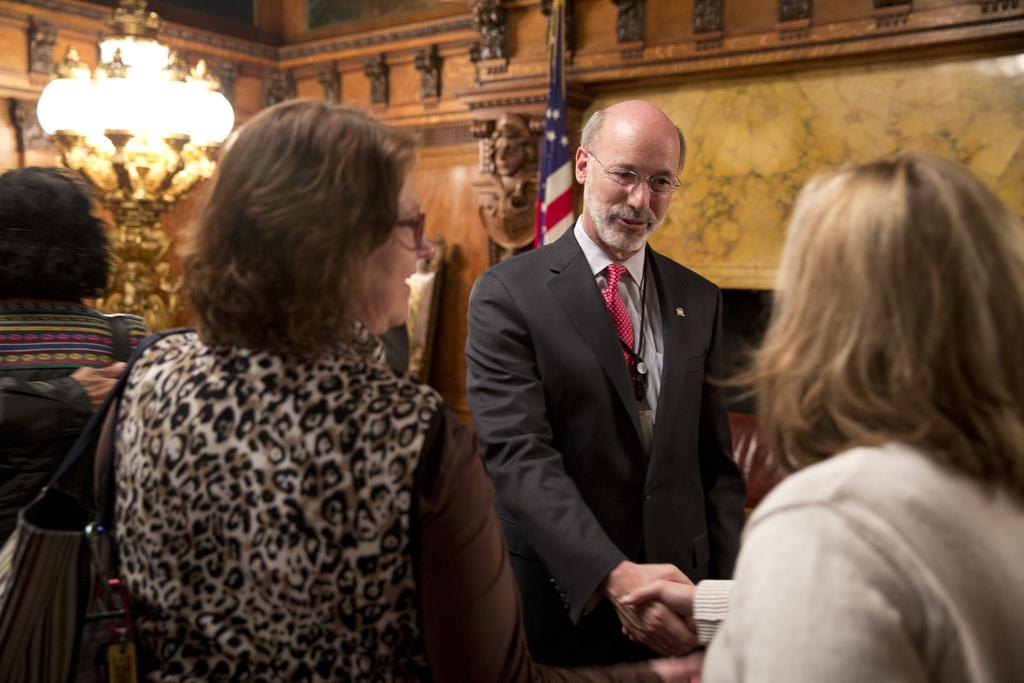How many people are present in the image? There are four persons standing in the image. What are two of the persons doing in the image? Two of the persons are handshaking each other. What can be seen in the background of the image? There is a chandelier, a flag, and a wall in the background of the image. What type of music is the band playing in the background of the image? There is no band present in the image, so it is not possible to determine what type of music might be playing. 